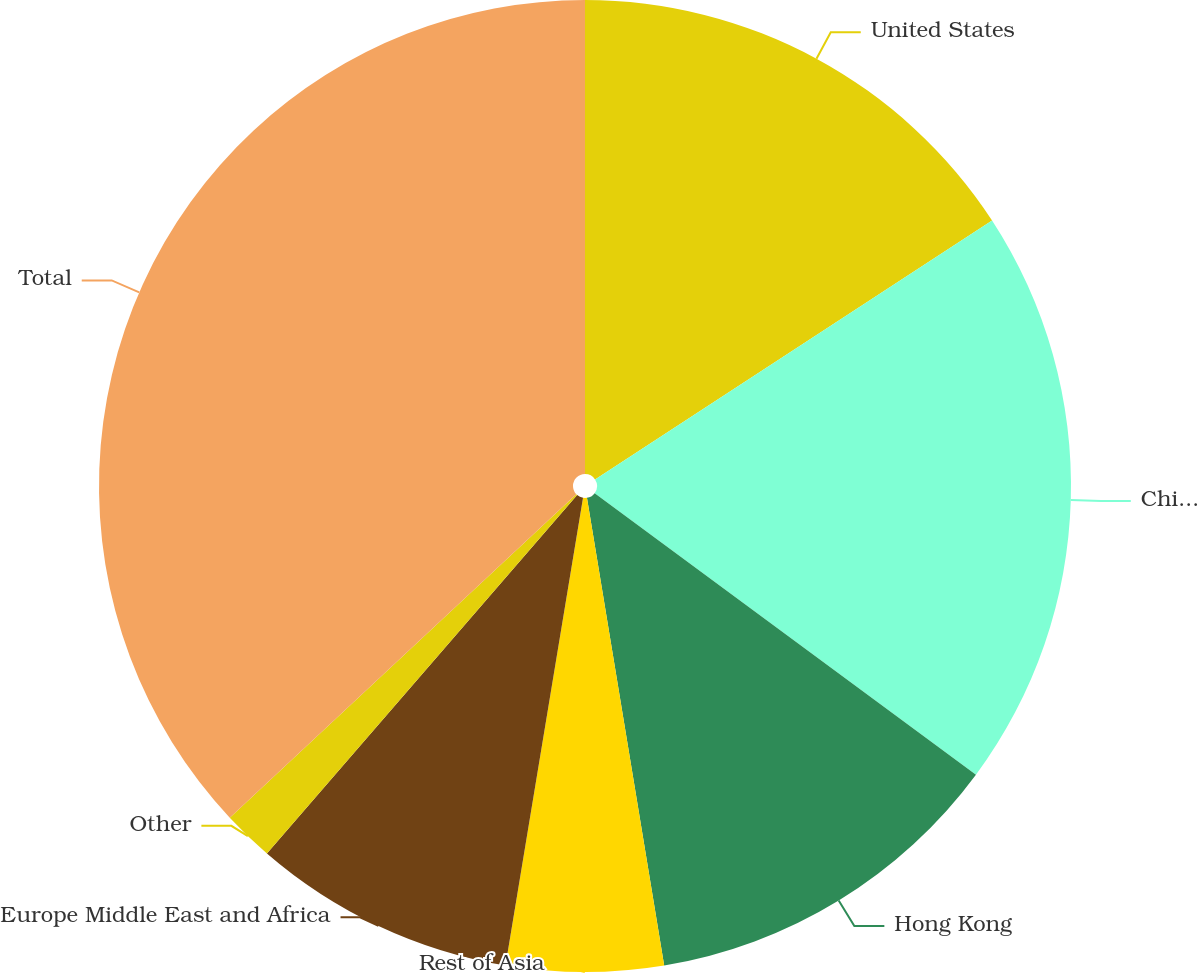Convert chart. <chart><loc_0><loc_0><loc_500><loc_500><pie_chart><fcel>United States<fcel>China<fcel>Hong Kong<fcel>Rest of Asia<fcel>Europe Middle East and Africa<fcel>Other<fcel>Total<nl><fcel>15.8%<fcel>19.32%<fcel>12.27%<fcel>5.22%<fcel>8.74%<fcel>1.69%<fcel>36.95%<nl></chart> 